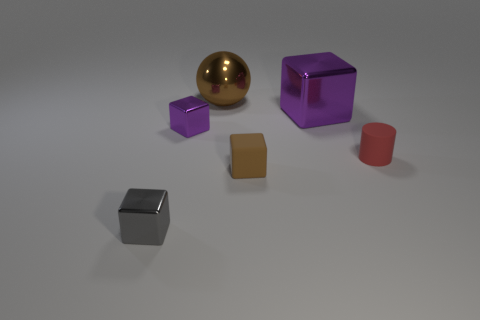Add 2 large brown objects. How many objects exist? 8 Subtract all spheres. How many objects are left? 5 Subtract all tiny blue metallic objects. Subtract all big balls. How many objects are left? 5 Add 4 tiny red cylinders. How many tiny red cylinders are left? 5 Add 4 big purple metallic things. How many big purple metallic things exist? 5 Subtract 0 yellow cylinders. How many objects are left? 6 